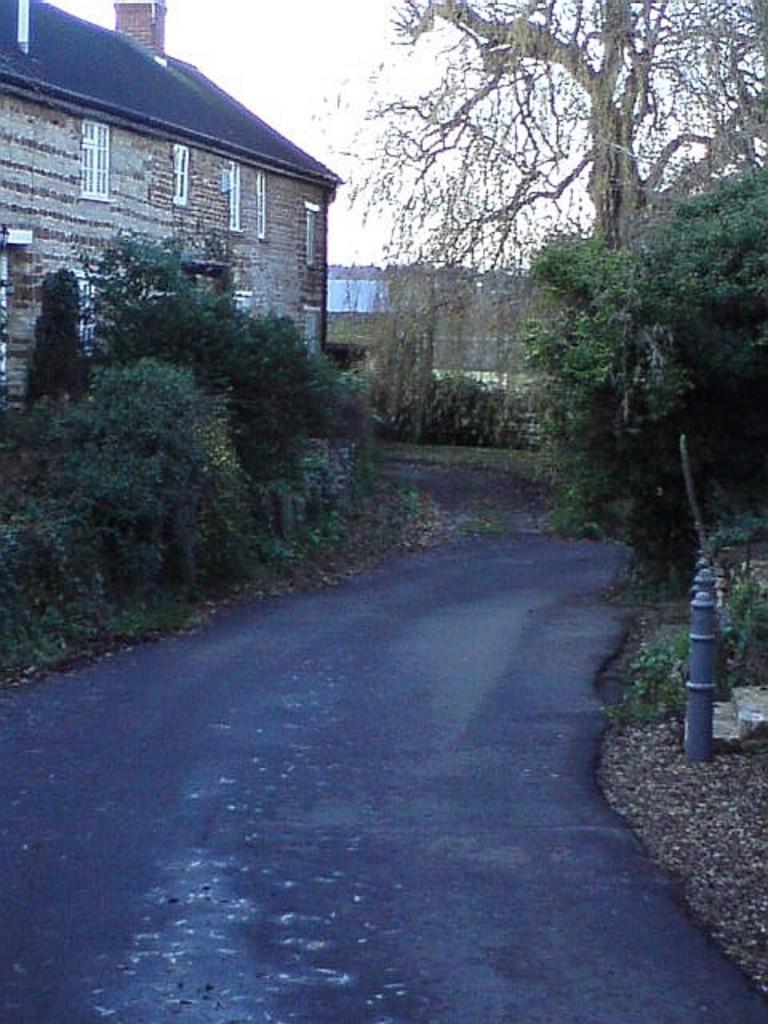In one or two sentences, can you explain what this image depicts? In the picture we can see some house building with some windows to it and just beside it, we can see some plants and a road and in the opposite direction we can see some plants and in the background we can see a sky. 